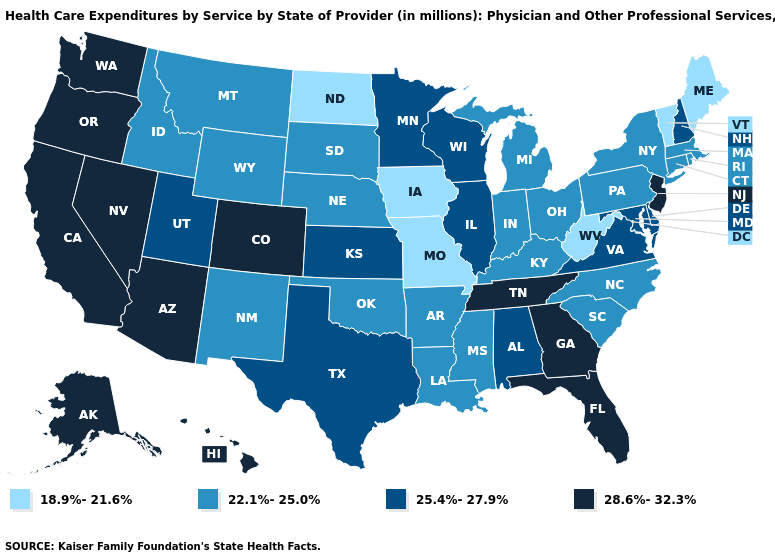Does the map have missing data?
Keep it brief. No. Which states have the lowest value in the South?
Write a very short answer. West Virginia. Is the legend a continuous bar?
Write a very short answer. No. What is the highest value in the USA?
Be succinct. 28.6%-32.3%. Does Maryland have a higher value than Alabama?
Answer briefly. No. Does the first symbol in the legend represent the smallest category?
Quick response, please. Yes. Name the states that have a value in the range 18.9%-21.6%?
Concise answer only. Iowa, Maine, Missouri, North Dakota, Vermont, West Virginia. Which states have the lowest value in the USA?
Short answer required. Iowa, Maine, Missouri, North Dakota, Vermont, West Virginia. Among the states that border Pennsylvania , does Maryland have the lowest value?
Keep it brief. No. Name the states that have a value in the range 28.6%-32.3%?
Write a very short answer. Alaska, Arizona, California, Colorado, Florida, Georgia, Hawaii, Nevada, New Jersey, Oregon, Tennessee, Washington. Which states hav the highest value in the Northeast?
Give a very brief answer. New Jersey. Among the states that border South Dakota , which have the lowest value?
Answer briefly. Iowa, North Dakota. Which states have the lowest value in the Northeast?
Write a very short answer. Maine, Vermont. Among the states that border North Dakota , does Minnesota have the highest value?
Keep it brief. Yes. 